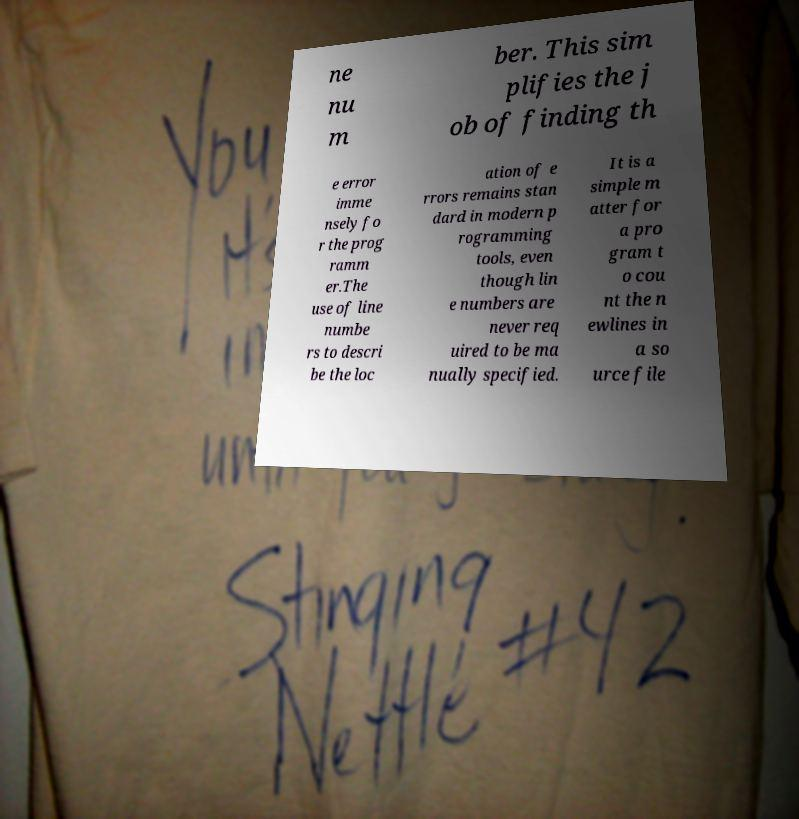Could you extract and type out the text from this image? ne nu m ber. This sim plifies the j ob of finding th e error imme nsely fo r the prog ramm er.The use of line numbe rs to descri be the loc ation of e rrors remains stan dard in modern p rogramming tools, even though lin e numbers are never req uired to be ma nually specified. It is a simple m atter for a pro gram t o cou nt the n ewlines in a so urce file 